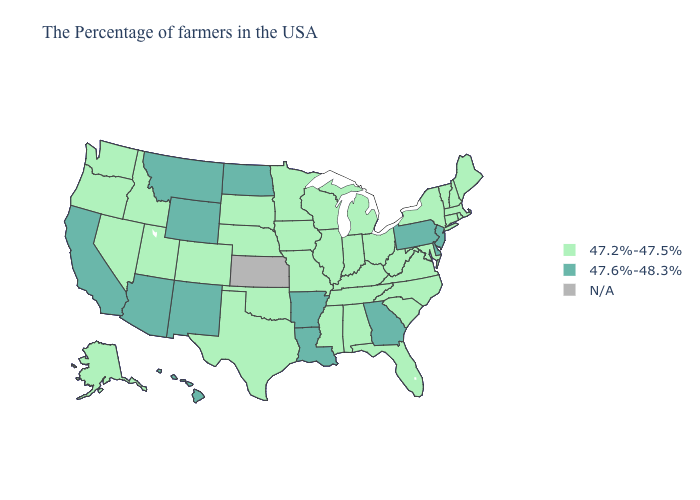Which states have the highest value in the USA?
Keep it brief. New Jersey, Delaware, Pennsylvania, Georgia, Louisiana, Arkansas, North Dakota, Wyoming, New Mexico, Montana, Arizona, California, Hawaii. Name the states that have a value in the range 47.2%-47.5%?
Give a very brief answer. Maine, Massachusetts, Rhode Island, New Hampshire, Vermont, Connecticut, New York, Maryland, Virginia, North Carolina, South Carolina, West Virginia, Ohio, Florida, Michigan, Kentucky, Indiana, Alabama, Tennessee, Wisconsin, Illinois, Mississippi, Missouri, Minnesota, Iowa, Nebraska, Oklahoma, Texas, South Dakota, Colorado, Utah, Idaho, Nevada, Washington, Oregon, Alaska. What is the value of Michigan?
Concise answer only. 47.2%-47.5%. Name the states that have a value in the range 47.6%-48.3%?
Give a very brief answer. New Jersey, Delaware, Pennsylvania, Georgia, Louisiana, Arkansas, North Dakota, Wyoming, New Mexico, Montana, Arizona, California, Hawaii. Name the states that have a value in the range 47.2%-47.5%?
Concise answer only. Maine, Massachusetts, Rhode Island, New Hampshire, Vermont, Connecticut, New York, Maryland, Virginia, North Carolina, South Carolina, West Virginia, Ohio, Florida, Michigan, Kentucky, Indiana, Alabama, Tennessee, Wisconsin, Illinois, Mississippi, Missouri, Minnesota, Iowa, Nebraska, Oklahoma, Texas, South Dakota, Colorado, Utah, Idaho, Nevada, Washington, Oregon, Alaska. What is the lowest value in the USA?
Keep it brief. 47.2%-47.5%. What is the value of Rhode Island?
Keep it brief. 47.2%-47.5%. What is the value of Georgia?
Answer briefly. 47.6%-48.3%. Which states hav the highest value in the West?
Concise answer only. Wyoming, New Mexico, Montana, Arizona, California, Hawaii. Does the map have missing data?
Be succinct. Yes. What is the value of Utah?
Short answer required. 47.2%-47.5%. Name the states that have a value in the range N/A?
Give a very brief answer. Kansas. What is the value of Montana?
Be succinct. 47.6%-48.3%. Which states have the highest value in the USA?
Give a very brief answer. New Jersey, Delaware, Pennsylvania, Georgia, Louisiana, Arkansas, North Dakota, Wyoming, New Mexico, Montana, Arizona, California, Hawaii. 